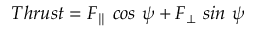Convert formula to latex. <formula><loc_0><loc_0><loc_500><loc_500>T h r u s t = F _ { \| } \ \cos \ \psi + F _ { \bot } \ \sin \ \psi</formula> 